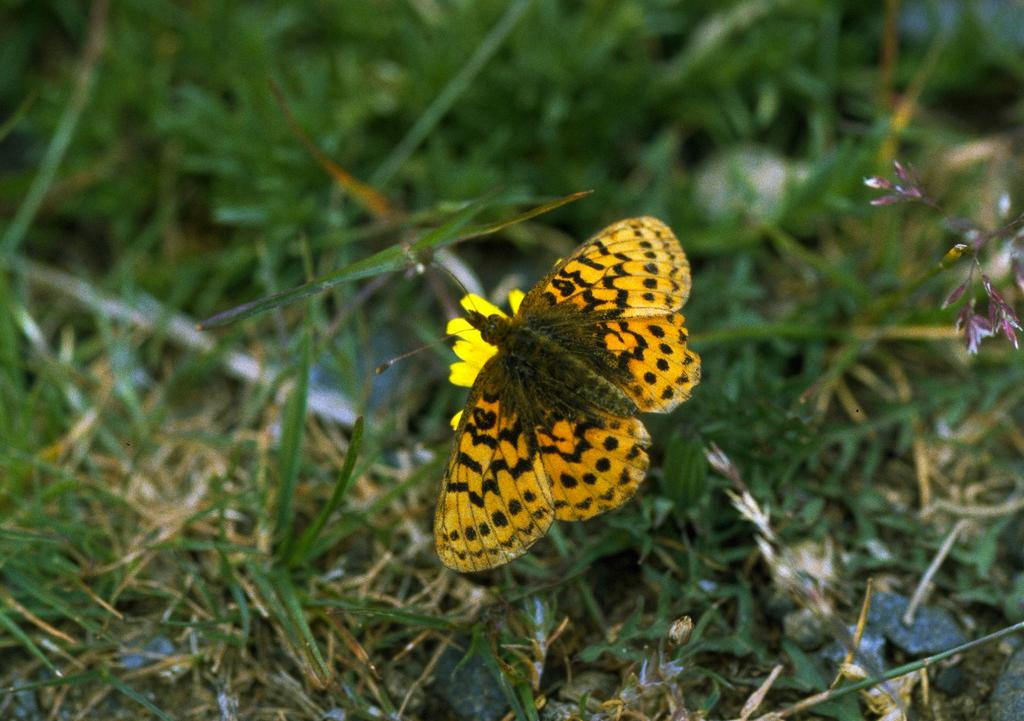What type of insect is in the image? There is a yellow butterfly in the image. Where is the butterfly located? The butterfly is sitting on the grass. What can be seen in the background of the image? The background of the image is green and blurred. What type of mine is visible in the image? There is no mine present in the image; it features a yellow butterfly sitting on the grass. What emotion is the butterfly displaying in the image? The butterfly is an insect and does not display emotions like anger. 